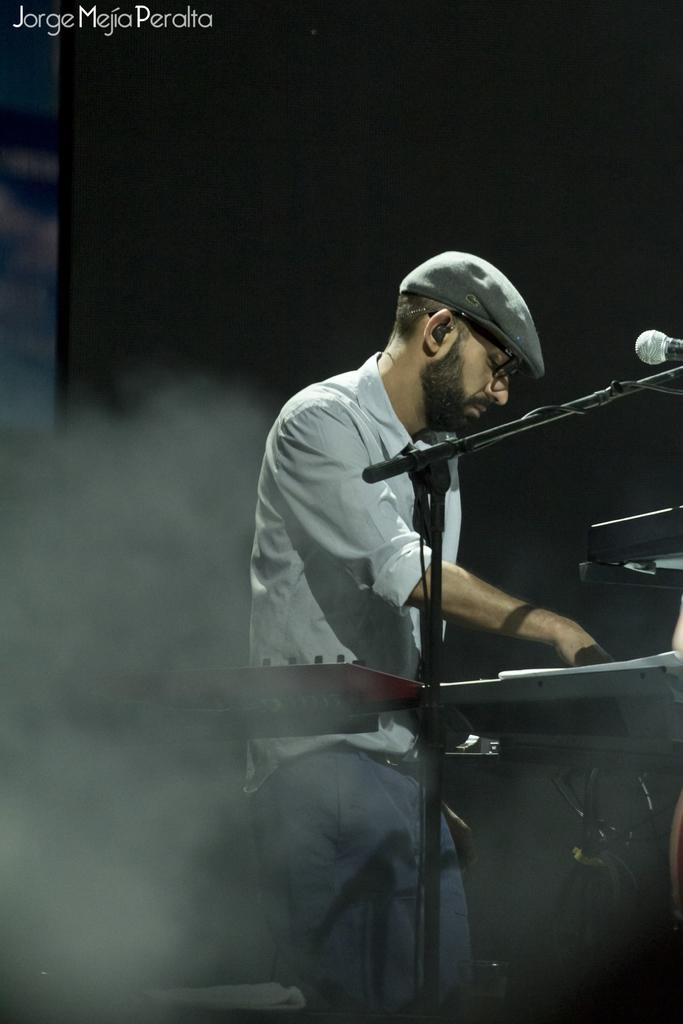What is the main subject of the image? The main subject of the image is a person playing musical instruments. What object is visible near the person? There is a microphone (mic) in the image. Where is the text located in the image? The text is in the top left side of the image. Can you see any bears playing with ducks in the library in the image? There is no library, bears, or ducks present in the image. 